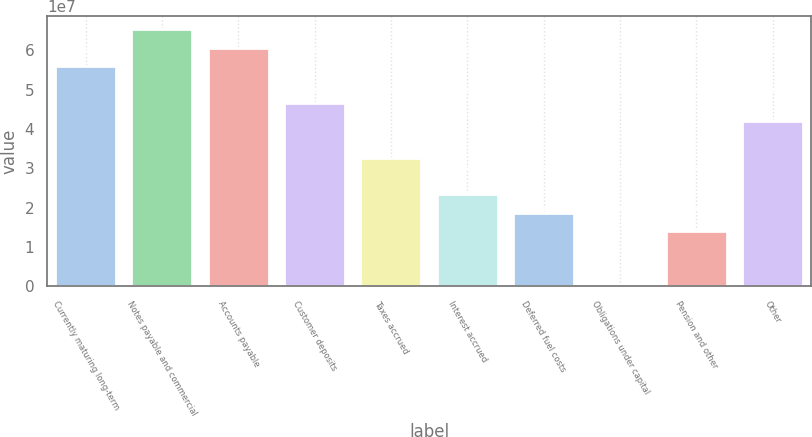Convert chart. <chart><loc_0><loc_0><loc_500><loc_500><bar_chart><fcel>Currently maturing long-term<fcel>Notes payable and commercial<fcel>Accounts payable<fcel>Customer deposits<fcel>Taxes accrued<fcel>Interest accrued<fcel>Deferred fuel costs<fcel>Obligations under capital<fcel>Pension and other<fcel>Other<nl><fcel>5.60483e+07<fcel>6.53894e+07<fcel>6.07188e+07<fcel>4.67071e+07<fcel>3.26955e+07<fcel>2.33543e+07<fcel>1.86838e+07<fcel>1502<fcel>1.40132e+07<fcel>4.20366e+07<nl></chart> 